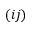Convert formula to latex. <formula><loc_0><loc_0><loc_500><loc_500>( i j )</formula> 